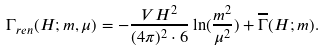Convert formula to latex. <formula><loc_0><loc_0><loc_500><loc_500>\Gamma _ { r e n } ( H ; m , \mu ) = - { \frac { V H ^ { 2 } } { ( 4 \pi ) ^ { 2 } \cdot 6 } } \ln ( { \frac { m ^ { 2 } } { \mu ^ { 2 } } } ) + \overline { \Gamma } ( H ; m ) .</formula> 